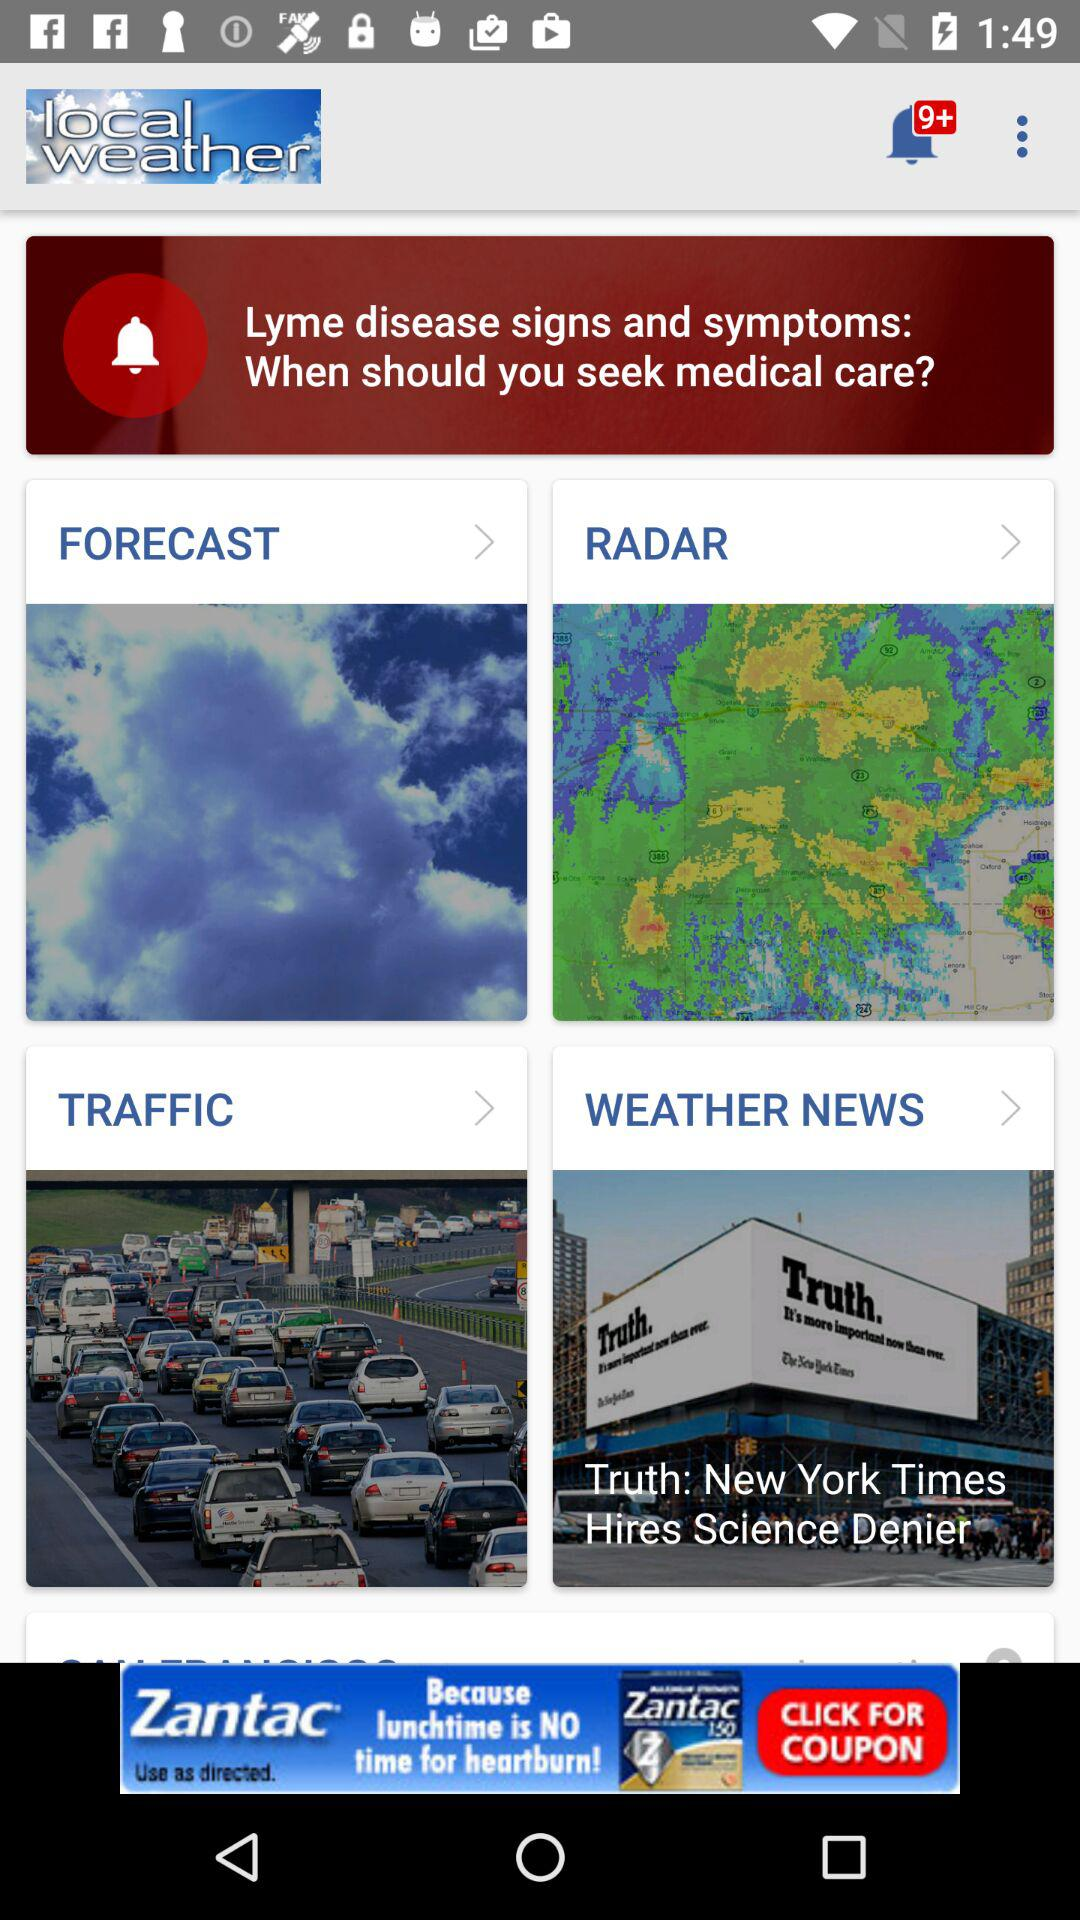What is the name of the application? The name of the application is "local weather". 